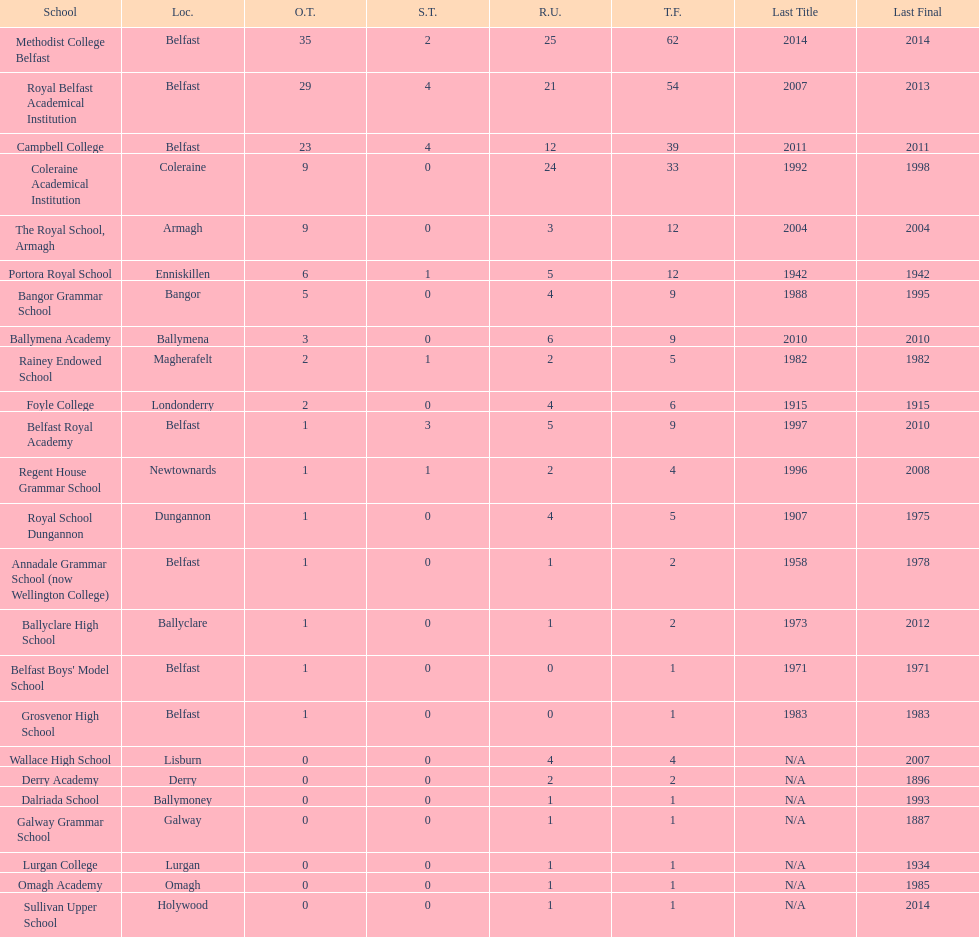Who has the most recent title win, campbell college or regent house grammar school? Campbell College. 